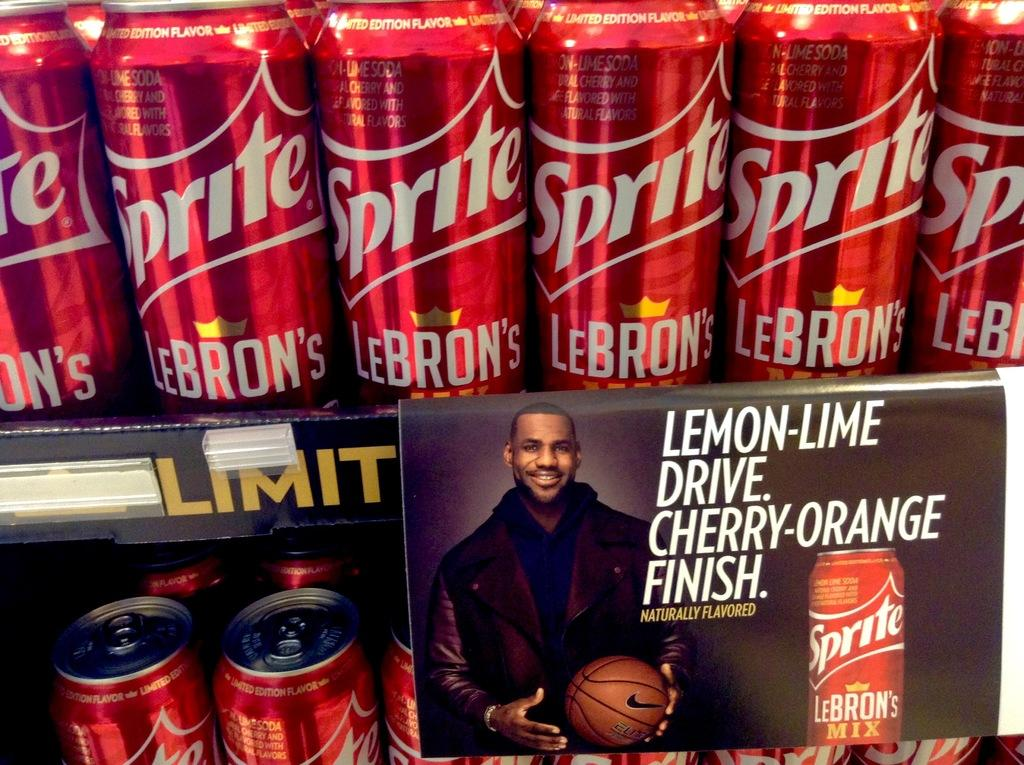<image>
Offer a succinct explanation of the picture presented. A shelf of red sprite cans with a poster that says lemon lime drive cherry orange finish 